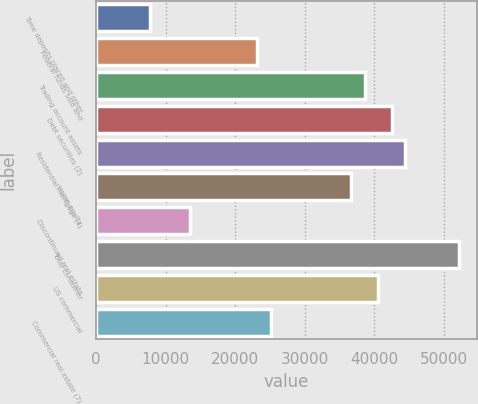Convert chart to OTSL. <chart><loc_0><loc_0><loc_500><loc_500><bar_chart><fcel>Time deposits placed and other<fcel>Federal funds sold and<fcel>Trading account assets<fcel>Debt securities (2)<fcel>Residential mortgage (4)<fcel>Home equity<fcel>Discontinued real estate<fcel>Total consumer<fcel>US commercial<fcel>Commercial real estate (7)<nl><fcel>7725.8<fcel>23171.4<fcel>38617<fcel>42478.4<fcel>44409.1<fcel>36686.3<fcel>13517.9<fcel>52131.9<fcel>40547.7<fcel>25102.1<nl></chart> 